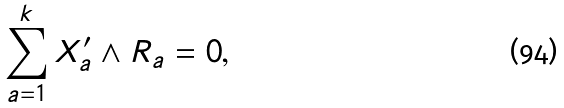<formula> <loc_0><loc_0><loc_500><loc_500>\sum _ { a = 1 } ^ { k } X ^ { \prime } _ { a } \wedge R _ { a } = 0 ,</formula> 